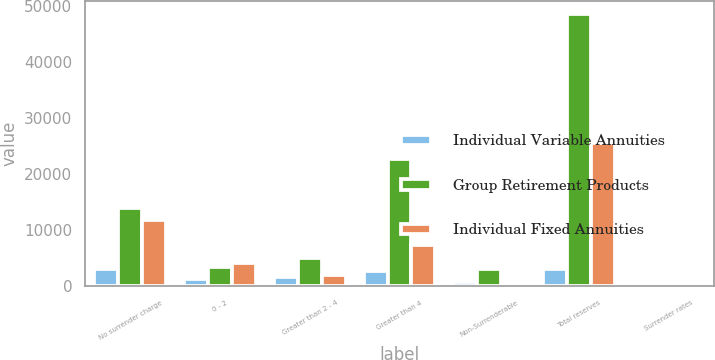Convert chart to OTSL. <chart><loc_0><loc_0><loc_500><loc_500><stacked_bar_chart><ecel><fcel>No surrender charge<fcel>0 - 2<fcel>Greater than 2 - 4<fcel>Greater than 4<fcel>Non-Surrenderable<fcel>Total reserves<fcel>Surrender rates<nl><fcel>Individual Variable Annuities<fcel>3136<fcel>1292<fcel>1754<fcel>2753<fcel>792<fcel>3136<fcel>10.3<nl><fcel>Group Retirement Products<fcel>14006<fcel>3510<fcel>5060<fcel>22777<fcel>3136<fcel>48489<fcel>7.4<nl><fcel>Individual Fixed Annuities<fcel>11859<fcel>4083<fcel>2040<fcel>7361<fcel>238<fcel>25581<fcel>11.4<nl></chart> 